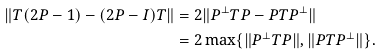<formula> <loc_0><loc_0><loc_500><loc_500>\| T ( 2 P - 1 ) - ( 2 P - I ) T \| & = 2 \| P ^ { \perp } T P - P T P ^ { \perp } \| \\ & = 2 \max \{ \| P ^ { \perp } T P \| , \| P T P ^ { \perp } \| \} .</formula> 